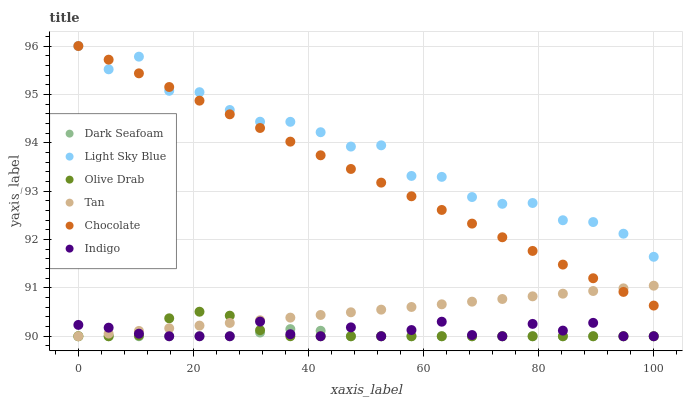Does Dark Seafoam have the minimum area under the curve?
Answer yes or no. Yes. Does Light Sky Blue have the maximum area under the curve?
Answer yes or no. Yes. Does Chocolate have the minimum area under the curve?
Answer yes or no. No. Does Chocolate have the maximum area under the curve?
Answer yes or no. No. Is Tan the smoothest?
Answer yes or no. Yes. Is Light Sky Blue the roughest?
Answer yes or no. Yes. Is Chocolate the smoothest?
Answer yes or no. No. Is Chocolate the roughest?
Answer yes or no. No. Does Indigo have the lowest value?
Answer yes or no. Yes. Does Chocolate have the lowest value?
Answer yes or no. No. Does Light Sky Blue have the highest value?
Answer yes or no. Yes. Does Dark Seafoam have the highest value?
Answer yes or no. No. Is Olive Drab less than Chocolate?
Answer yes or no. Yes. Is Light Sky Blue greater than Olive Drab?
Answer yes or no. Yes. Does Chocolate intersect Tan?
Answer yes or no. Yes. Is Chocolate less than Tan?
Answer yes or no. No. Is Chocolate greater than Tan?
Answer yes or no. No. Does Olive Drab intersect Chocolate?
Answer yes or no. No. 